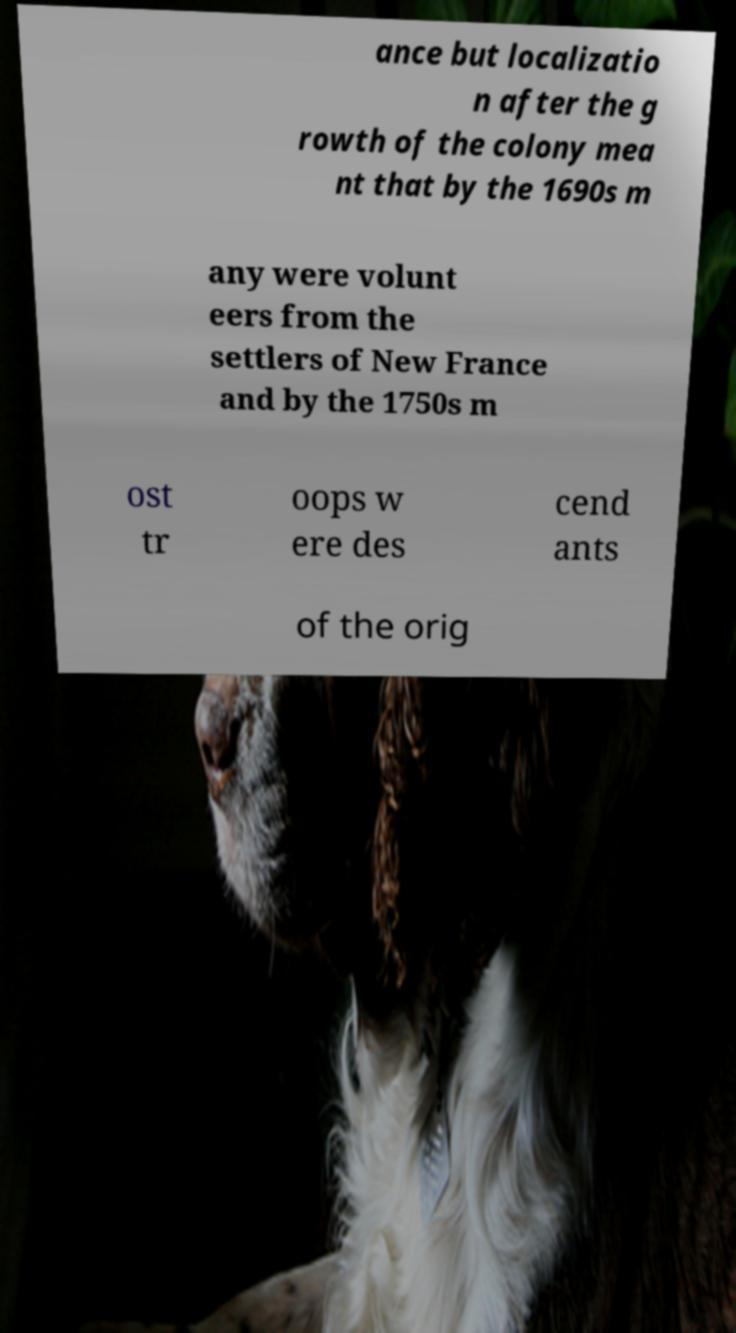For documentation purposes, I need the text within this image transcribed. Could you provide that? ance but localizatio n after the g rowth of the colony mea nt that by the 1690s m any were volunt eers from the settlers of New France and by the 1750s m ost tr oops w ere des cend ants of the orig 